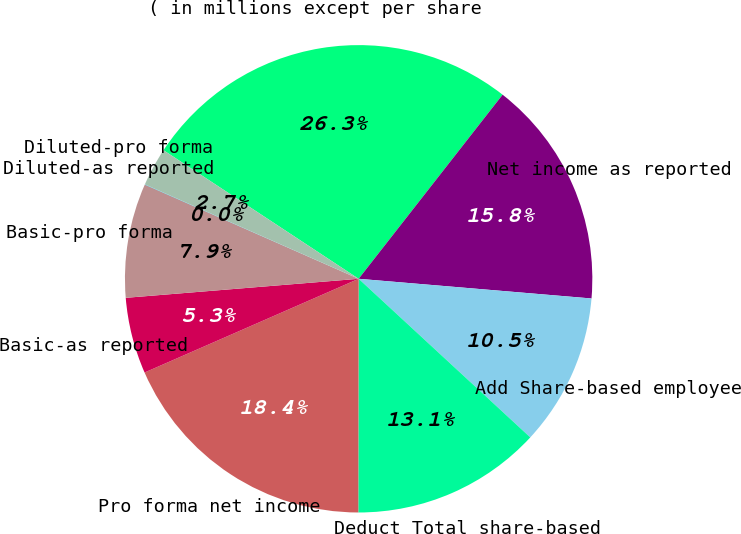Convert chart. <chart><loc_0><loc_0><loc_500><loc_500><pie_chart><fcel>( in millions except per share<fcel>Net income as reported<fcel>Add Share-based employee<fcel>Deduct Total share-based<fcel>Pro forma net income<fcel>Basic-as reported<fcel>Basic-pro forma<fcel>Diluted-as reported<fcel>Diluted-pro forma<nl><fcel>26.29%<fcel>15.78%<fcel>10.53%<fcel>13.15%<fcel>18.41%<fcel>5.27%<fcel>7.9%<fcel>0.02%<fcel>2.65%<nl></chart> 